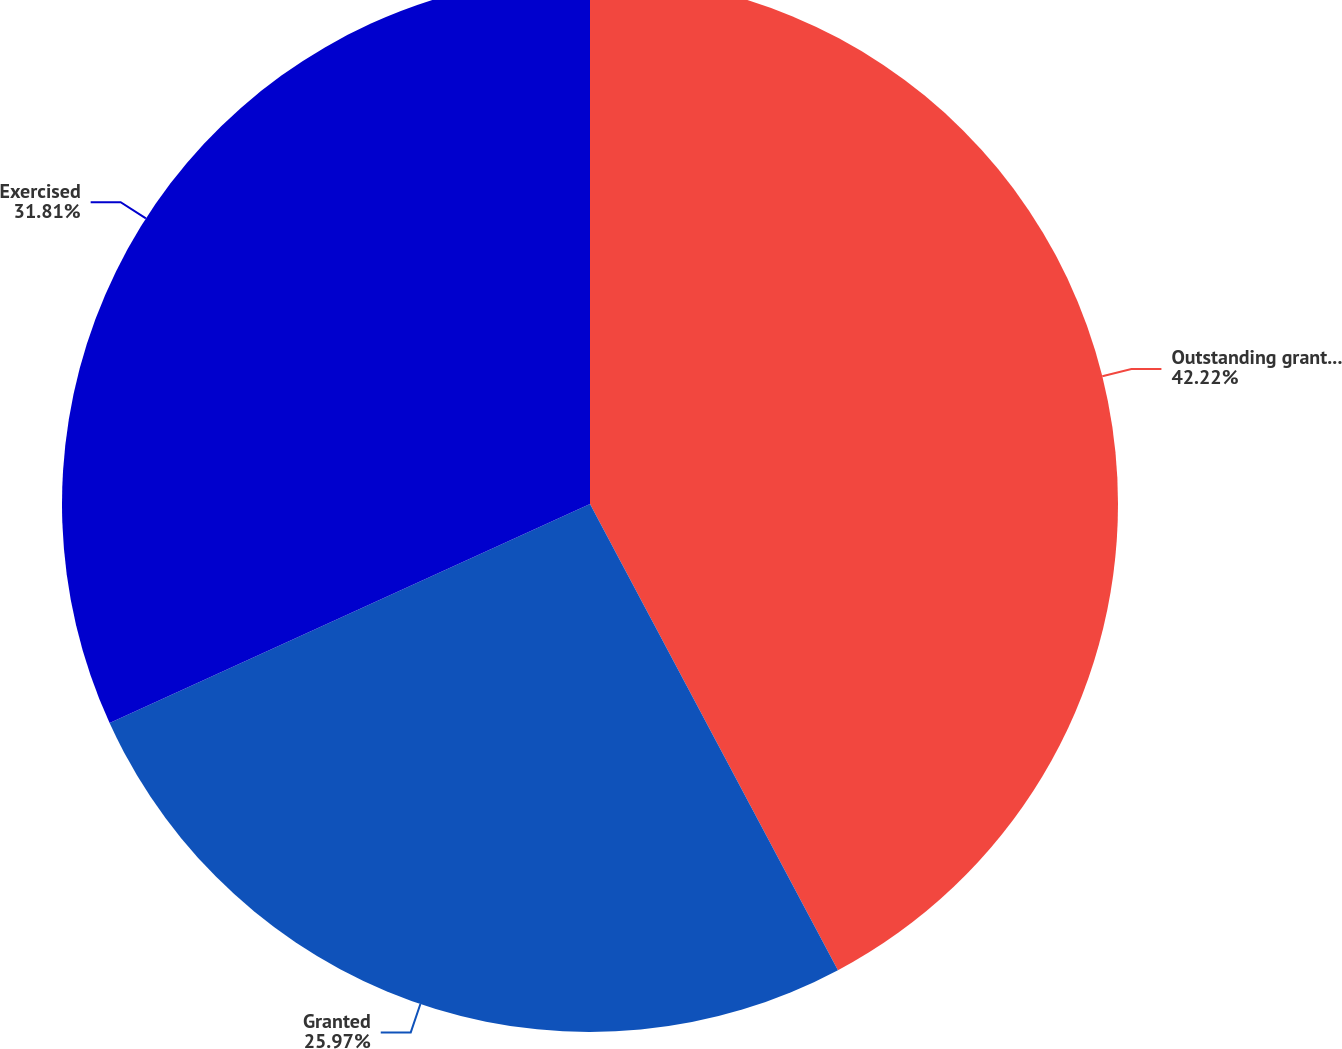<chart> <loc_0><loc_0><loc_500><loc_500><pie_chart><fcel>Outstanding grants December 31<fcel>Granted<fcel>Exercised<nl><fcel>42.22%<fcel>25.97%<fcel>31.81%<nl></chart> 